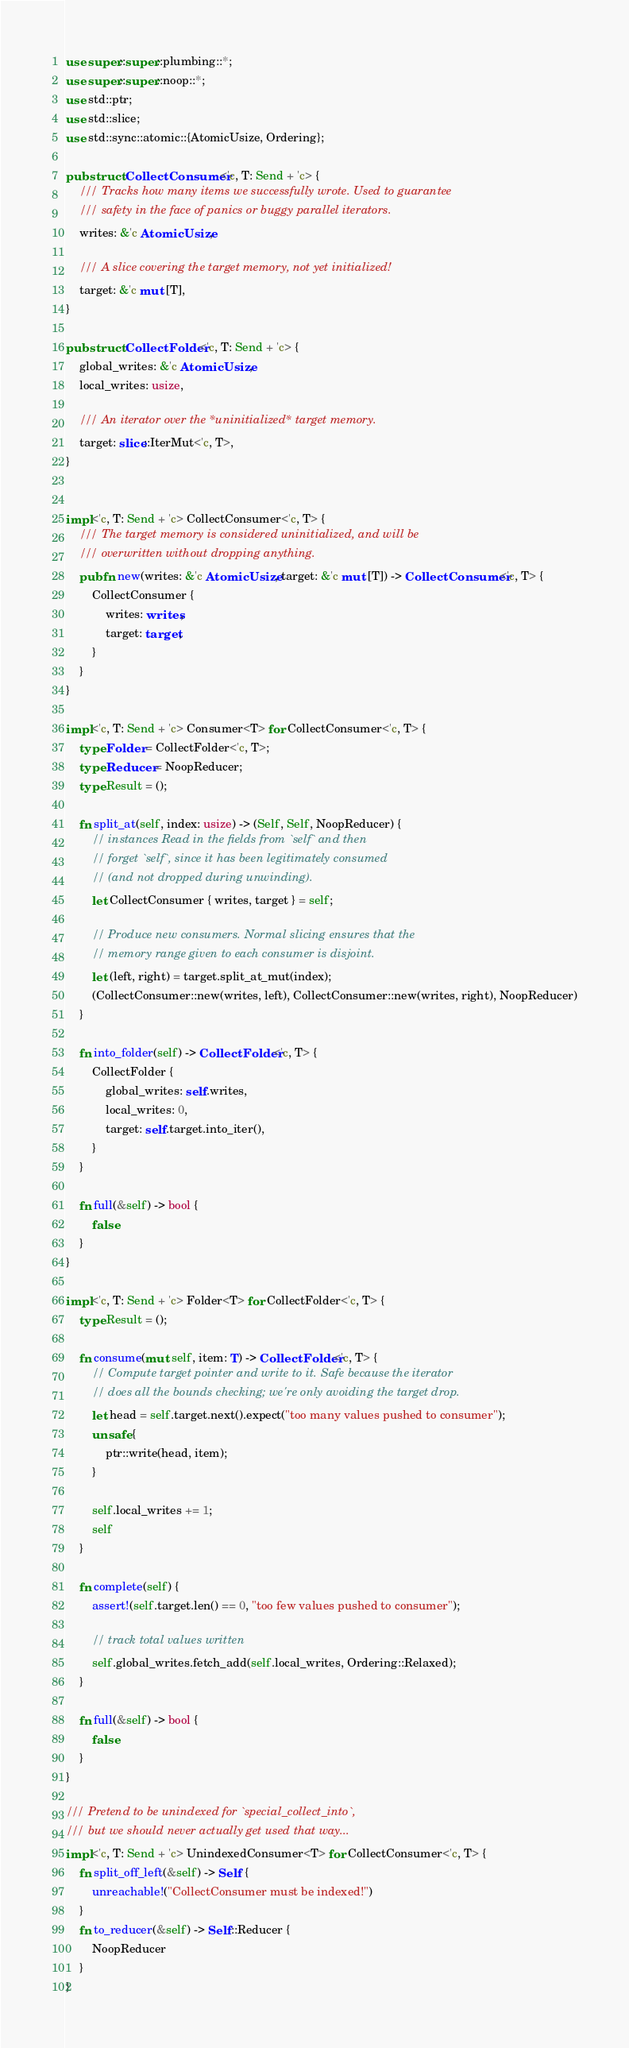<code> <loc_0><loc_0><loc_500><loc_500><_Rust_>use super::super::plumbing::*;
use super::super::noop::*;
use std::ptr;
use std::slice;
use std::sync::atomic::{AtomicUsize, Ordering};

pub struct CollectConsumer<'c, T: Send + 'c> {
    /// Tracks how many items we successfully wrote. Used to guarantee
    /// safety in the face of panics or buggy parallel iterators.
    writes: &'c AtomicUsize,

    /// A slice covering the target memory, not yet initialized!
    target: &'c mut [T],
}

pub struct CollectFolder<'c, T: Send + 'c> {
    global_writes: &'c AtomicUsize,
    local_writes: usize,

    /// An iterator over the *uninitialized* target memory.
    target: slice::IterMut<'c, T>,
}


impl<'c, T: Send + 'c> CollectConsumer<'c, T> {
    /// The target memory is considered uninitialized, and will be
    /// overwritten without dropping anything.
    pub fn new(writes: &'c AtomicUsize, target: &'c mut [T]) -> CollectConsumer<'c, T> {
        CollectConsumer {
            writes: writes,
            target: target,
        }
    }
}

impl<'c, T: Send + 'c> Consumer<T> for CollectConsumer<'c, T> {
    type Folder = CollectFolder<'c, T>;
    type Reducer = NoopReducer;
    type Result = ();

    fn split_at(self, index: usize) -> (Self, Self, NoopReducer) {
        // instances Read in the fields from `self` and then
        // forget `self`, since it has been legitimately consumed
        // (and not dropped during unwinding).
        let CollectConsumer { writes, target } = self;

        // Produce new consumers. Normal slicing ensures that the
        // memory range given to each consumer is disjoint.
        let (left, right) = target.split_at_mut(index);
        (CollectConsumer::new(writes, left), CollectConsumer::new(writes, right), NoopReducer)
    }

    fn into_folder(self) -> CollectFolder<'c, T> {
        CollectFolder {
            global_writes: self.writes,
            local_writes: 0,
            target: self.target.into_iter(),
        }
    }

    fn full(&self) -> bool {
        false
    }
}

impl<'c, T: Send + 'c> Folder<T> for CollectFolder<'c, T> {
    type Result = ();

    fn consume(mut self, item: T) -> CollectFolder<'c, T> {
        // Compute target pointer and write to it. Safe because the iterator
        // does all the bounds checking; we're only avoiding the target drop.
        let head = self.target.next().expect("too many values pushed to consumer");
        unsafe {
            ptr::write(head, item);
        }

        self.local_writes += 1;
        self
    }

    fn complete(self) {
        assert!(self.target.len() == 0, "too few values pushed to consumer");

        // track total values written
        self.global_writes.fetch_add(self.local_writes, Ordering::Relaxed);
    }

    fn full(&self) -> bool {
        false
    }
}

/// Pretend to be unindexed for `special_collect_into`,
/// but we should never actually get used that way...
impl<'c, T: Send + 'c> UnindexedConsumer<T> for CollectConsumer<'c, T> {
    fn split_off_left(&self) -> Self {
        unreachable!("CollectConsumer must be indexed!")
    }
    fn to_reducer(&self) -> Self::Reducer {
        NoopReducer
    }
}
</code> 